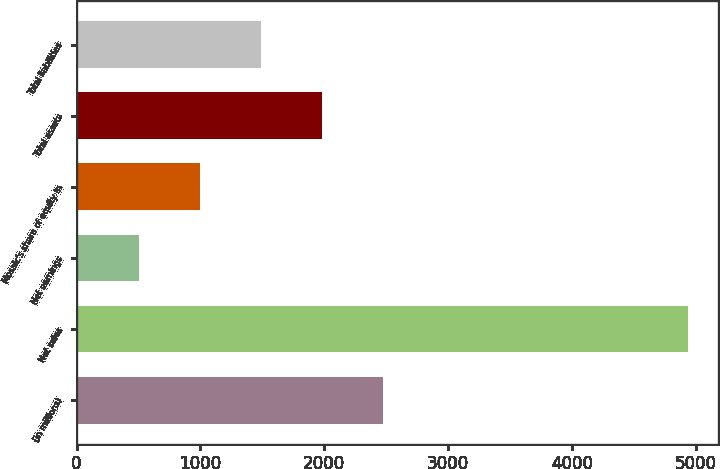<chart> <loc_0><loc_0><loc_500><loc_500><bar_chart><fcel>(in millions)<fcel>Net sales<fcel>Net earnings<fcel>Mosaic's share of equity in<fcel>Total assets<fcel>Total liabilities<nl><fcel>2475.85<fcel>4938.4<fcel>505.81<fcel>998.32<fcel>1983.34<fcel>1490.83<nl></chart> 